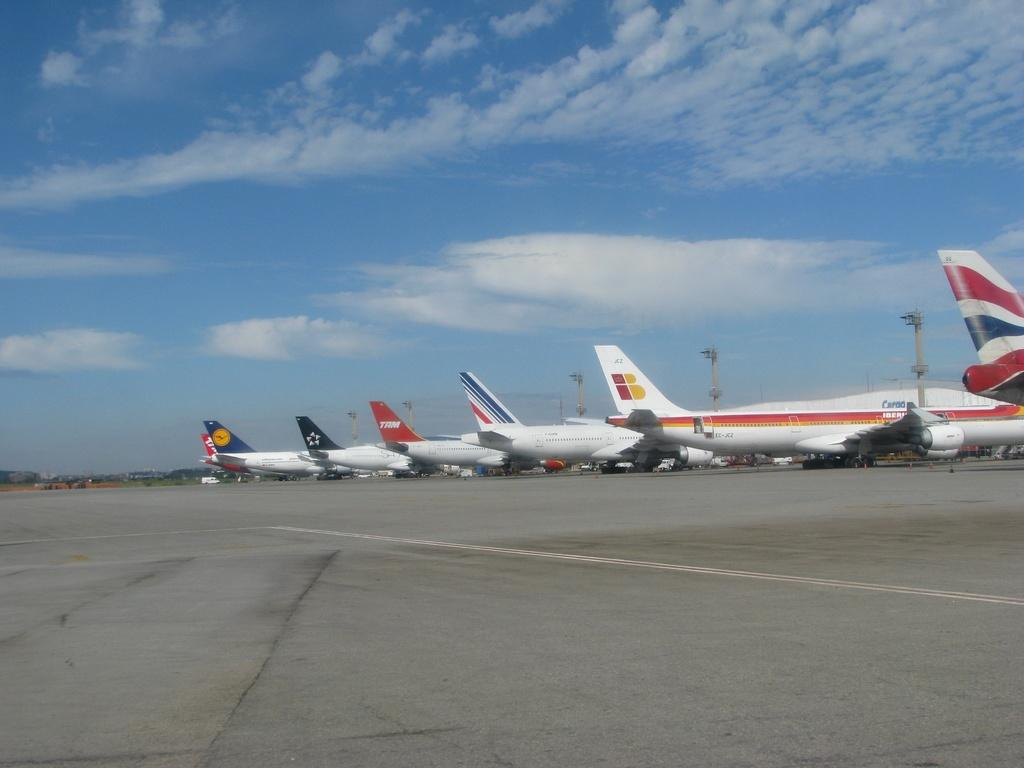What is happening on the runway in the image? There are flights on the runway in the image. What other objects can be seen in the image besides the flights? There are poles and cables in the image. What is visible in the sky in the image? There are clouds in the sky in the image. Can you tell me how many grains of rice are on the runway in the image? There is no rice present in the image, so it is not possible to determine the number of grains. 